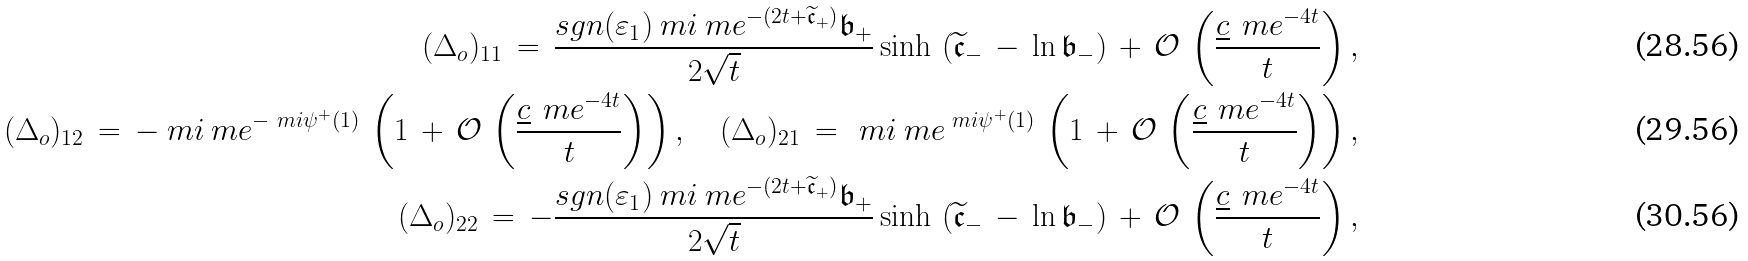Convert formula to latex. <formula><loc_0><loc_0><loc_500><loc_500>( \Delta _ { o } ) _ { 1 1 } \, = \, \frac { s g n ( \varepsilon _ { 1 } ) \ m i \ m e ^ { - ( 2 t + \widetilde { \mathfrak { c } } _ { + } ) } \mathfrak { b } _ { + } } { 2 \sqrt { t } } \sinh \, \left ( \widetilde { \mathfrak { c } } _ { - } \, - \, \ln \mathfrak { b } _ { - } \right ) \, + \, \mathcal { O } \, \left ( \frac { \underline { c } \, \ m e ^ { - 4 t } } { t } \right ) , \\ ( \Delta _ { o } ) _ { 1 2 } \, = \, - \ m i \ m e ^ { - \ m i \psi ^ { + } ( 1 ) } \, \left ( 1 \, + \, \mathcal { O } \, \left ( \frac { \underline { c } \, \ m e ^ { - 4 t } } { t } \right ) \right ) , \quad ( \Delta _ { o } ) _ { 2 1 } \, = \, \ m i \ m e ^ { \ m i \psi ^ { + } ( 1 ) } \, \left ( 1 \, + \, \mathcal { O } \, \left ( \frac { \underline { c } \, \ m e ^ { - 4 t } } { t } \right ) \right ) , \\ ( \Delta _ { o } ) _ { 2 2 } \, = \, - \frac { s g n ( \varepsilon _ { 1 } ) \ m i \ m e ^ { - ( 2 t + \widetilde { \mathfrak { c } } _ { + } ) } \mathfrak { b } _ { + } } { 2 \sqrt { t } } \sinh \, \left ( \widetilde { \mathfrak { c } } _ { - } \, - \, \ln \mathfrak { b } _ { - } \right ) \, + \, \mathcal { O } \, \left ( \frac { \underline { c } \, \ m e ^ { - 4 t } } { t } \right ) ,</formula> 